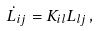Convert formula to latex. <formula><loc_0><loc_0><loc_500><loc_500>\dot { L } _ { i j } = K _ { i l } L _ { l j } \, ,</formula> 